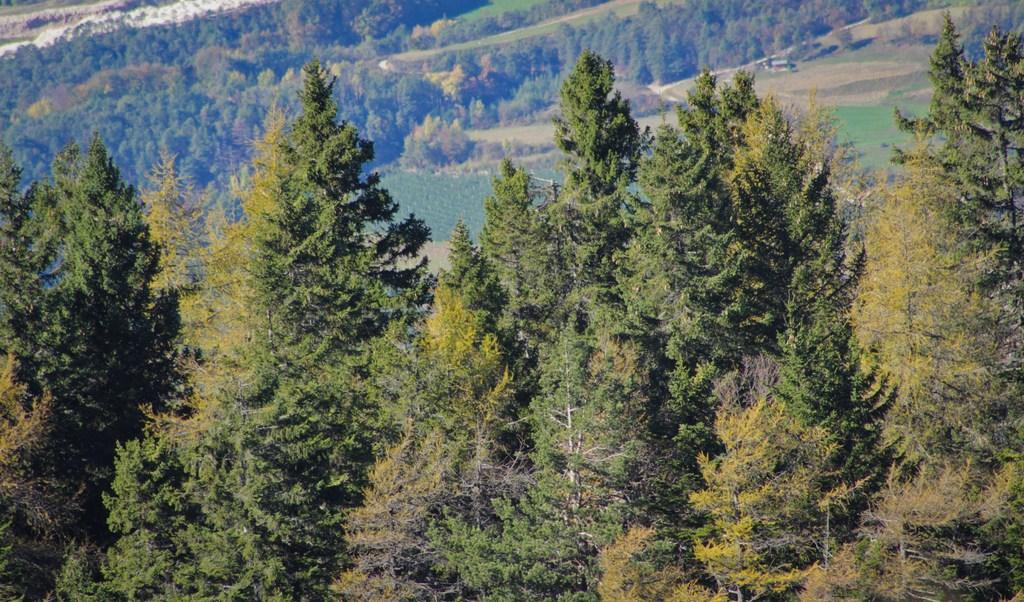What type of vegetation can be seen in the image? There are trees and grass in the image. Can you describe the natural environment depicted in the image? The image features trees and grass, which are common elements of natural landscapes. What book is the tongue reading in the image? There is no book or tongue present in the image; it only features trees and grass. 